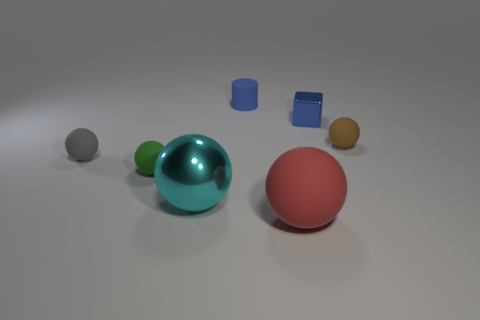Subtract all cyan metallic balls. How many balls are left? 4 Add 1 cylinders. How many objects exist? 8 Subtract all brown spheres. How many spheres are left? 4 Subtract all spheres. How many objects are left? 2 Subtract 3 balls. How many balls are left? 2 Subtract all blue balls. Subtract all cyan cubes. How many balls are left? 5 Subtract all green spheres. How many purple cubes are left? 0 Subtract all large yellow shiny balls. Subtract all cyan metallic objects. How many objects are left? 6 Add 2 metallic objects. How many metallic objects are left? 4 Add 7 small brown balls. How many small brown balls exist? 8 